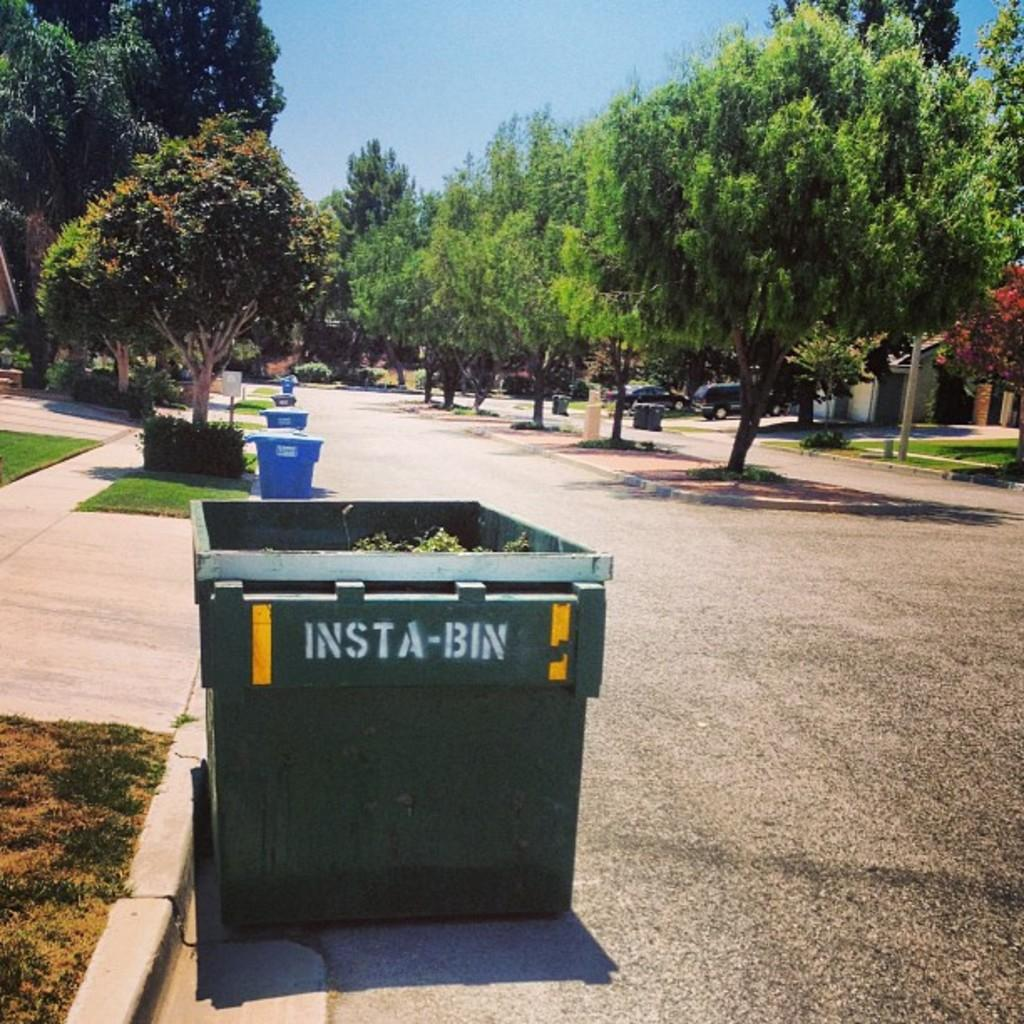<image>
Write a terse but informative summary of the picture. An insta-bin is on the curb for trash pick up on a tree lined street. 